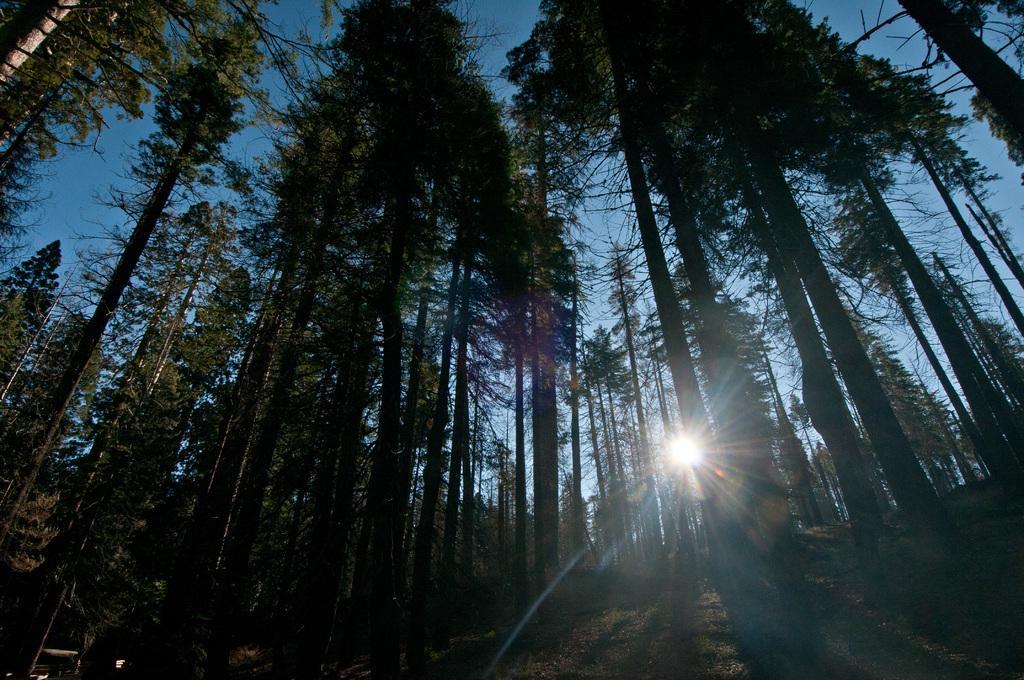Describe this image in one or two sentences. The picture is clicked in woods. In this picture there are trees and grass. In the background it is sun shining in the sky. 